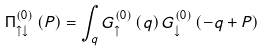Convert formula to latex. <formula><loc_0><loc_0><loc_500><loc_500>\Pi ^ { \left ( 0 \right ) } _ { \uparrow \downarrow } \left ( P \right ) = \int _ { q } G ^ { \left ( 0 \right ) } _ { \uparrow } \left ( q \right ) G ^ { \left ( 0 \right ) } _ { \downarrow } \left ( - q + P \right )</formula> 